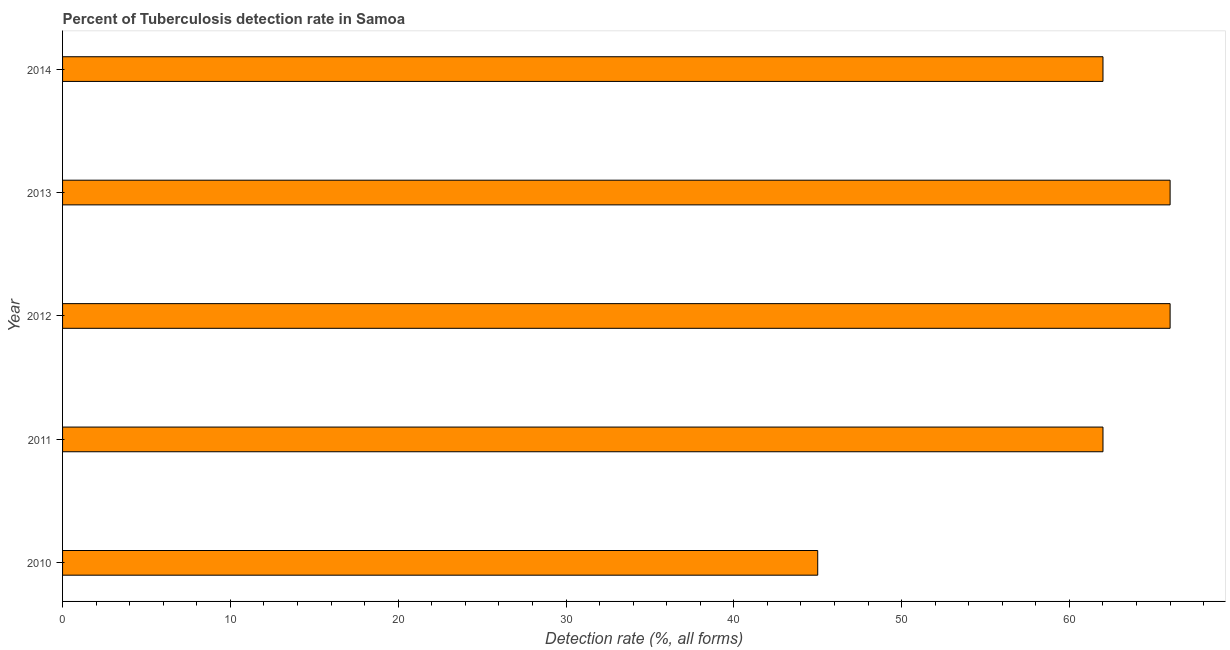What is the title of the graph?
Ensure brevity in your answer.  Percent of Tuberculosis detection rate in Samoa. What is the label or title of the X-axis?
Your answer should be compact. Detection rate (%, all forms). What is the label or title of the Y-axis?
Your answer should be compact. Year. What is the detection rate of tuberculosis in 2010?
Your answer should be compact. 45. In which year was the detection rate of tuberculosis maximum?
Offer a terse response. 2012. In which year was the detection rate of tuberculosis minimum?
Your response must be concise. 2010. What is the sum of the detection rate of tuberculosis?
Provide a succinct answer. 301. What is the difference between the detection rate of tuberculosis in 2010 and 2013?
Offer a terse response. -21. What is the average detection rate of tuberculosis per year?
Offer a terse response. 60. What is the median detection rate of tuberculosis?
Keep it short and to the point. 62. What is the ratio of the detection rate of tuberculosis in 2010 to that in 2012?
Offer a very short reply. 0.68. Is the difference between the detection rate of tuberculosis in 2012 and 2013 greater than the difference between any two years?
Give a very brief answer. No. What is the difference between the highest and the second highest detection rate of tuberculosis?
Keep it short and to the point. 0. Is the sum of the detection rate of tuberculosis in 2010 and 2014 greater than the maximum detection rate of tuberculosis across all years?
Make the answer very short. Yes. In how many years, is the detection rate of tuberculosis greater than the average detection rate of tuberculosis taken over all years?
Your answer should be very brief. 4. How many bars are there?
Make the answer very short. 5. Are all the bars in the graph horizontal?
Keep it short and to the point. Yes. What is the difference between two consecutive major ticks on the X-axis?
Offer a terse response. 10. What is the Detection rate (%, all forms) in 2010?
Your answer should be very brief. 45. What is the Detection rate (%, all forms) in 2011?
Offer a very short reply. 62. What is the Detection rate (%, all forms) of 2013?
Offer a terse response. 66. What is the Detection rate (%, all forms) of 2014?
Give a very brief answer. 62. What is the difference between the Detection rate (%, all forms) in 2010 and 2013?
Your response must be concise. -21. What is the difference between the Detection rate (%, all forms) in 2012 and 2013?
Your answer should be compact. 0. What is the ratio of the Detection rate (%, all forms) in 2010 to that in 2011?
Offer a terse response. 0.73. What is the ratio of the Detection rate (%, all forms) in 2010 to that in 2012?
Your response must be concise. 0.68. What is the ratio of the Detection rate (%, all forms) in 2010 to that in 2013?
Offer a very short reply. 0.68. What is the ratio of the Detection rate (%, all forms) in 2010 to that in 2014?
Offer a terse response. 0.73. What is the ratio of the Detection rate (%, all forms) in 2011 to that in 2012?
Provide a succinct answer. 0.94. What is the ratio of the Detection rate (%, all forms) in 2011 to that in 2013?
Your response must be concise. 0.94. What is the ratio of the Detection rate (%, all forms) in 2012 to that in 2014?
Provide a succinct answer. 1.06. What is the ratio of the Detection rate (%, all forms) in 2013 to that in 2014?
Provide a short and direct response. 1.06. 